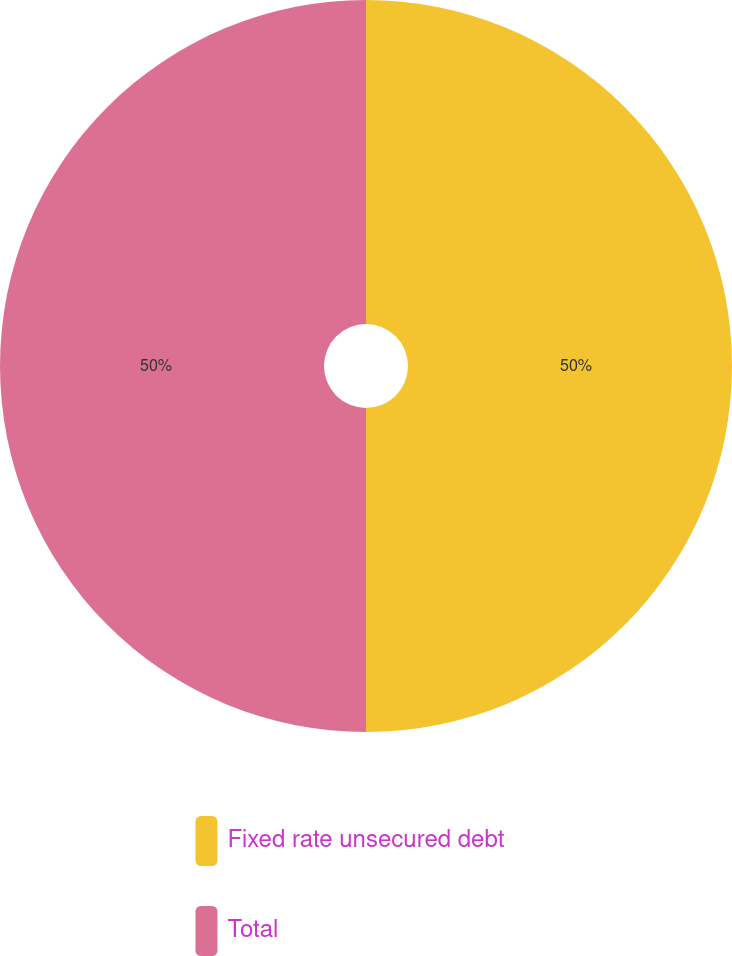Convert chart to OTSL. <chart><loc_0><loc_0><loc_500><loc_500><pie_chart><fcel>Fixed rate unsecured debt<fcel>Total<nl><fcel>50.0%<fcel>50.0%<nl></chart> 